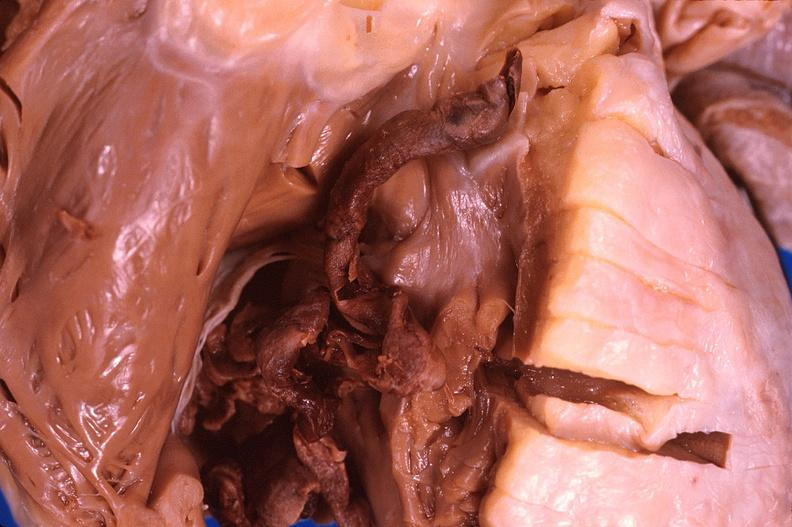s subdiaphragmatic abscess present?
Answer the question using a single word or phrase. No 